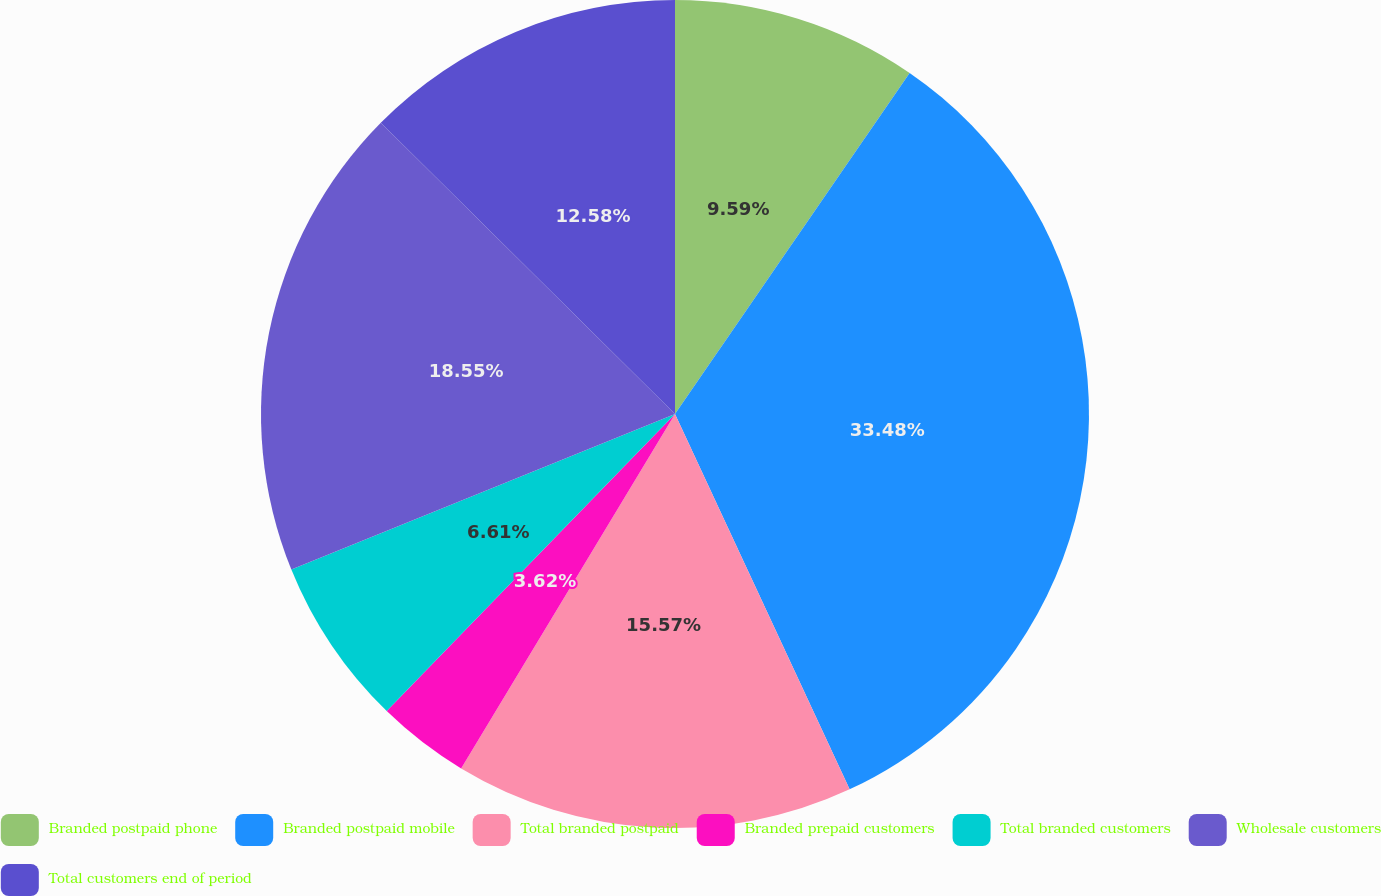Convert chart to OTSL. <chart><loc_0><loc_0><loc_500><loc_500><pie_chart><fcel>Branded postpaid phone<fcel>Branded postpaid mobile<fcel>Total branded postpaid<fcel>Branded prepaid customers<fcel>Total branded customers<fcel>Wholesale customers<fcel>Total customers end of period<nl><fcel>9.59%<fcel>33.48%<fcel>15.57%<fcel>3.62%<fcel>6.61%<fcel>18.55%<fcel>12.58%<nl></chart> 